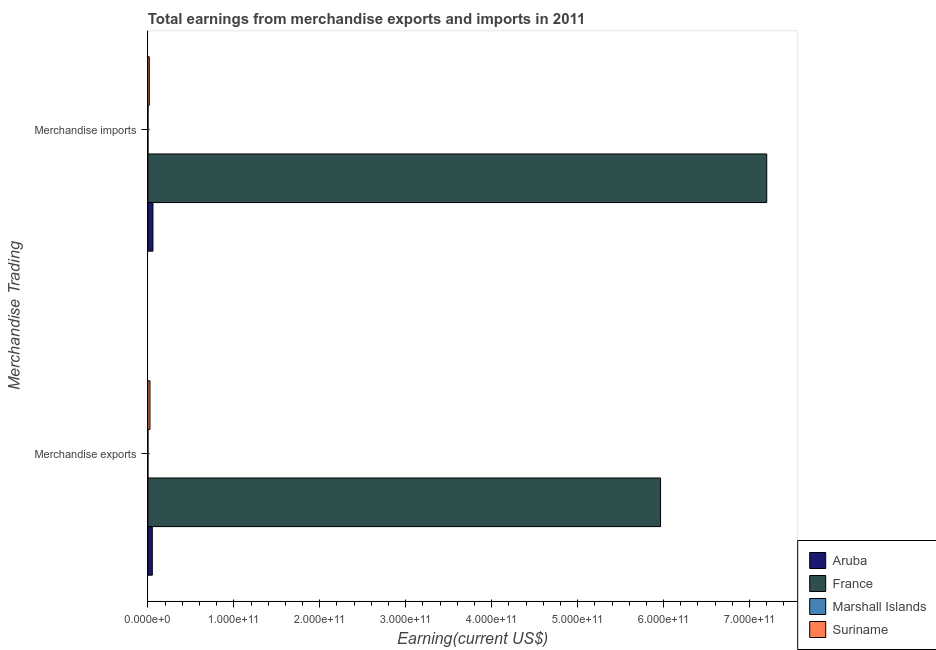How many groups of bars are there?
Offer a very short reply. 2. Are the number of bars per tick equal to the number of legend labels?
Make the answer very short. Yes. Are the number of bars on each tick of the Y-axis equal?
Provide a short and direct response. Yes. What is the label of the 2nd group of bars from the top?
Offer a terse response. Merchandise exports. What is the earnings from merchandise imports in Suriname?
Provide a short and direct response. 1.64e+09. Across all countries, what is the maximum earnings from merchandise exports?
Make the answer very short. 5.96e+11. Across all countries, what is the minimum earnings from merchandise imports?
Your response must be concise. 1.30e+08. In which country was the earnings from merchandise imports minimum?
Provide a succinct answer. Marshall Islands. What is the total earnings from merchandise exports in the graph?
Keep it short and to the point. 6.04e+11. What is the difference between the earnings from merchandise exports in France and that in Suriname?
Your response must be concise. 5.94e+11. What is the difference between the earnings from merchandise exports in Suriname and the earnings from merchandise imports in Aruba?
Make the answer very short. -3.45e+09. What is the average earnings from merchandise imports per country?
Offer a terse response. 1.82e+11. What is the difference between the earnings from merchandise exports and earnings from merchandise imports in Aruba?
Your answer should be very brief. -7.37e+08. In how many countries, is the earnings from merchandise exports greater than 340000000000 US$?
Provide a succinct answer. 1. What is the ratio of the earnings from merchandise imports in Suriname to that in France?
Offer a very short reply. 0. Is the earnings from merchandise imports in Suriname less than that in Aruba?
Your answer should be very brief. Yes. In how many countries, is the earnings from merchandise imports greater than the average earnings from merchandise imports taken over all countries?
Provide a short and direct response. 1. What does the 3rd bar from the top in Merchandise imports represents?
Provide a succinct answer. France. What does the 3rd bar from the bottom in Merchandise exports represents?
Provide a short and direct response. Marshall Islands. Are all the bars in the graph horizontal?
Your answer should be very brief. Yes. What is the difference between two consecutive major ticks on the X-axis?
Your answer should be compact. 1.00e+11. Are the values on the major ticks of X-axis written in scientific E-notation?
Ensure brevity in your answer.  Yes. Does the graph contain any zero values?
Offer a very short reply. No. Does the graph contain grids?
Your answer should be very brief. No. Where does the legend appear in the graph?
Your response must be concise. Bottom right. How many legend labels are there?
Your answer should be very brief. 4. How are the legend labels stacked?
Give a very brief answer. Vertical. What is the title of the graph?
Provide a succinct answer. Total earnings from merchandise exports and imports in 2011. Does "Azerbaijan" appear as one of the legend labels in the graph?
Provide a succinct answer. No. What is the label or title of the X-axis?
Your response must be concise. Earning(current US$). What is the label or title of the Y-axis?
Your answer should be very brief. Merchandise Trading. What is the Earning(current US$) of Aruba in Merchandise exports?
Make the answer very short. 5.18e+09. What is the Earning(current US$) of France in Merchandise exports?
Give a very brief answer. 5.96e+11. What is the Earning(current US$) of Marshall Islands in Merchandise exports?
Offer a terse response. 5.01e+07. What is the Earning(current US$) in Suriname in Merchandise exports?
Give a very brief answer. 2.47e+09. What is the Earning(current US$) of Aruba in Merchandise imports?
Your response must be concise. 5.92e+09. What is the Earning(current US$) of France in Merchandise imports?
Offer a terse response. 7.20e+11. What is the Earning(current US$) in Marshall Islands in Merchandise imports?
Ensure brevity in your answer.  1.30e+08. What is the Earning(current US$) of Suriname in Merchandise imports?
Give a very brief answer. 1.64e+09. Across all Merchandise Trading, what is the maximum Earning(current US$) in Aruba?
Your answer should be compact. 5.92e+09. Across all Merchandise Trading, what is the maximum Earning(current US$) in France?
Offer a very short reply. 7.20e+11. Across all Merchandise Trading, what is the maximum Earning(current US$) in Marshall Islands?
Your response must be concise. 1.30e+08. Across all Merchandise Trading, what is the maximum Earning(current US$) of Suriname?
Your response must be concise. 2.47e+09. Across all Merchandise Trading, what is the minimum Earning(current US$) of Aruba?
Give a very brief answer. 5.18e+09. Across all Merchandise Trading, what is the minimum Earning(current US$) of France?
Keep it short and to the point. 5.96e+11. Across all Merchandise Trading, what is the minimum Earning(current US$) in Marshall Islands?
Offer a very short reply. 5.01e+07. Across all Merchandise Trading, what is the minimum Earning(current US$) of Suriname?
Your answer should be very brief. 1.64e+09. What is the total Earning(current US$) of Aruba in the graph?
Keep it short and to the point. 1.11e+1. What is the total Earning(current US$) in France in the graph?
Offer a terse response. 1.32e+12. What is the total Earning(current US$) of Marshall Islands in the graph?
Provide a short and direct response. 1.80e+08. What is the total Earning(current US$) in Suriname in the graph?
Keep it short and to the point. 4.10e+09. What is the difference between the Earning(current US$) of Aruba in Merchandise exports and that in Merchandise imports?
Your answer should be very brief. -7.37e+08. What is the difference between the Earning(current US$) in France in Merchandise exports and that in Merchandise imports?
Give a very brief answer. -1.24e+11. What is the difference between the Earning(current US$) of Marshall Islands in Merchandise exports and that in Merchandise imports?
Offer a terse response. -7.99e+07. What is the difference between the Earning(current US$) of Suriname in Merchandise exports and that in Merchandise imports?
Offer a very short reply. 8.29e+08. What is the difference between the Earning(current US$) of Aruba in Merchandise exports and the Earning(current US$) of France in Merchandise imports?
Provide a short and direct response. -7.15e+11. What is the difference between the Earning(current US$) of Aruba in Merchandise exports and the Earning(current US$) of Marshall Islands in Merchandise imports?
Keep it short and to the point. 5.05e+09. What is the difference between the Earning(current US$) in Aruba in Merchandise exports and the Earning(current US$) in Suriname in Merchandise imports?
Make the answer very short. 3.54e+09. What is the difference between the Earning(current US$) of France in Merchandise exports and the Earning(current US$) of Marshall Islands in Merchandise imports?
Offer a very short reply. 5.96e+11. What is the difference between the Earning(current US$) of France in Merchandise exports and the Earning(current US$) of Suriname in Merchandise imports?
Your answer should be very brief. 5.95e+11. What is the difference between the Earning(current US$) in Marshall Islands in Merchandise exports and the Earning(current US$) in Suriname in Merchandise imports?
Offer a terse response. -1.59e+09. What is the average Earning(current US$) in Aruba per Merchandise Trading?
Your answer should be compact. 5.55e+09. What is the average Earning(current US$) in France per Merchandise Trading?
Offer a very short reply. 6.58e+11. What is the average Earning(current US$) in Marshall Islands per Merchandise Trading?
Your answer should be compact. 9.00e+07. What is the average Earning(current US$) in Suriname per Merchandise Trading?
Provide a short and direct response. 2.05e+09. What is the difference between the Earning(current US$) of Aruba and Earning(current US$) of France in Merchandise exports?
Your answer should be compact. -5.91e+11. What is the difference between the Earning(current US$) of Aruba and Earning(current US$) of Marshall Islands in Merchandise exports?
Your response must be concise. 5.13e+09. What is the difference between the Earning(current US$) of Aruba and Earning(current US$) of Suriname in Merchandise exports?
Keep it short and to the point. 2.71e+09. What is the difference between the Earning(current US$) of France and Earning(current US$) of Marshall Islands in Merchandise exports?
Provide a short and direct response. 5.96e+11. What is the difference between the Earning(current US$) of France and Earning(current US$) of Suriname in Merchandise exports?
Give a very brief answer. 5.94e+11. What is the difference between the Earning(current US$) of Marshall Islands and Earning(current US$) of Suriname in Merchandise exports?
Keep it short and to the point. -2.42e+09. What is the difference between the Earning(current US$) in Aruba and Earning(current US$) in France in Merchandise imports?
Make the answer very short. -7.14e+11. What is the difference between the Earning(current US$) in Aruba and Earning(current US$) in Marshall Islands in Merchandise imports?
Your response must be concise. 5.79e+09. What is the difference between the Earning(current US$) of Aruba and Earning(current US$) of Suriname in Merchandise imports?
Your answer should be compact. 4.28e+09. What is the difference between the Earning(current US$) in France and Earning(current US$) in Marshall Islands in Merchandise imports?
Your answer should be very brief. 7.20e+11. What is the difference between the Earning(current US$) of France and Earning(current US$) of Suriname in Merchandise imports?
Your answer should be compact. 7.18e+11. What is the difference between the Earning(current US$) in Marshall Islands and Earning(current US$) in Suriname in Merchandise imports?
Keep it short and to the point. -1.51e+09. What is the ratio of the Earning(current US$) in Aruba in Merchandise exports to that in Merchandise imports?
Offer a terse response. 0.88. What is the ratio of the Earning(current US$) of France in Merchandise exports to that in Merchandise imports?
Offer a terse response. 0.83. What is the ratio of the Earning(current US$) in Marshall Islands in Merchandise exports to that in Merchandise imports?
Your answer should be very brief. 0.39. What is the ratio of the Earning(current US$) of Suriname in Merchandise exports to that in Merchandise imports?
Offer a very short reply. 1.51. What is the difference between the highest and the second highest Earning(current US$) of Aruba?
Keep it short and to the point. 7.37e+08. What is the difference between the highest and the second highest Earning(current US$) in France?
Your answer should be very brief. 1.24e+11. What is the difference between the highest and the second highest Earning(current US$) of Marshall Islands?
Offer a terse response. 7.99e+07. What is the difference between the highest and the second highest Earning(current US$) in Suriname?
Offer a very short reply. 8.29e+08. What is the difference between the highest and the lowest Earning(current US$) of Aruba?
Keep it short and to the point. 7.37e+08. What is the difference between the highest and the lowest Earning(current US$) of France?
Keep it short and to the point. 1.24e+11. What is the difference between the highest and the lowest Earning(current US$) of Marshall Islands?
Make the answer very short. 7.99e+07. What is the difference between the highest and the lowest Earning(current US$) in Suriname?
Ensure brevity in your answer.  8.29e+08. 